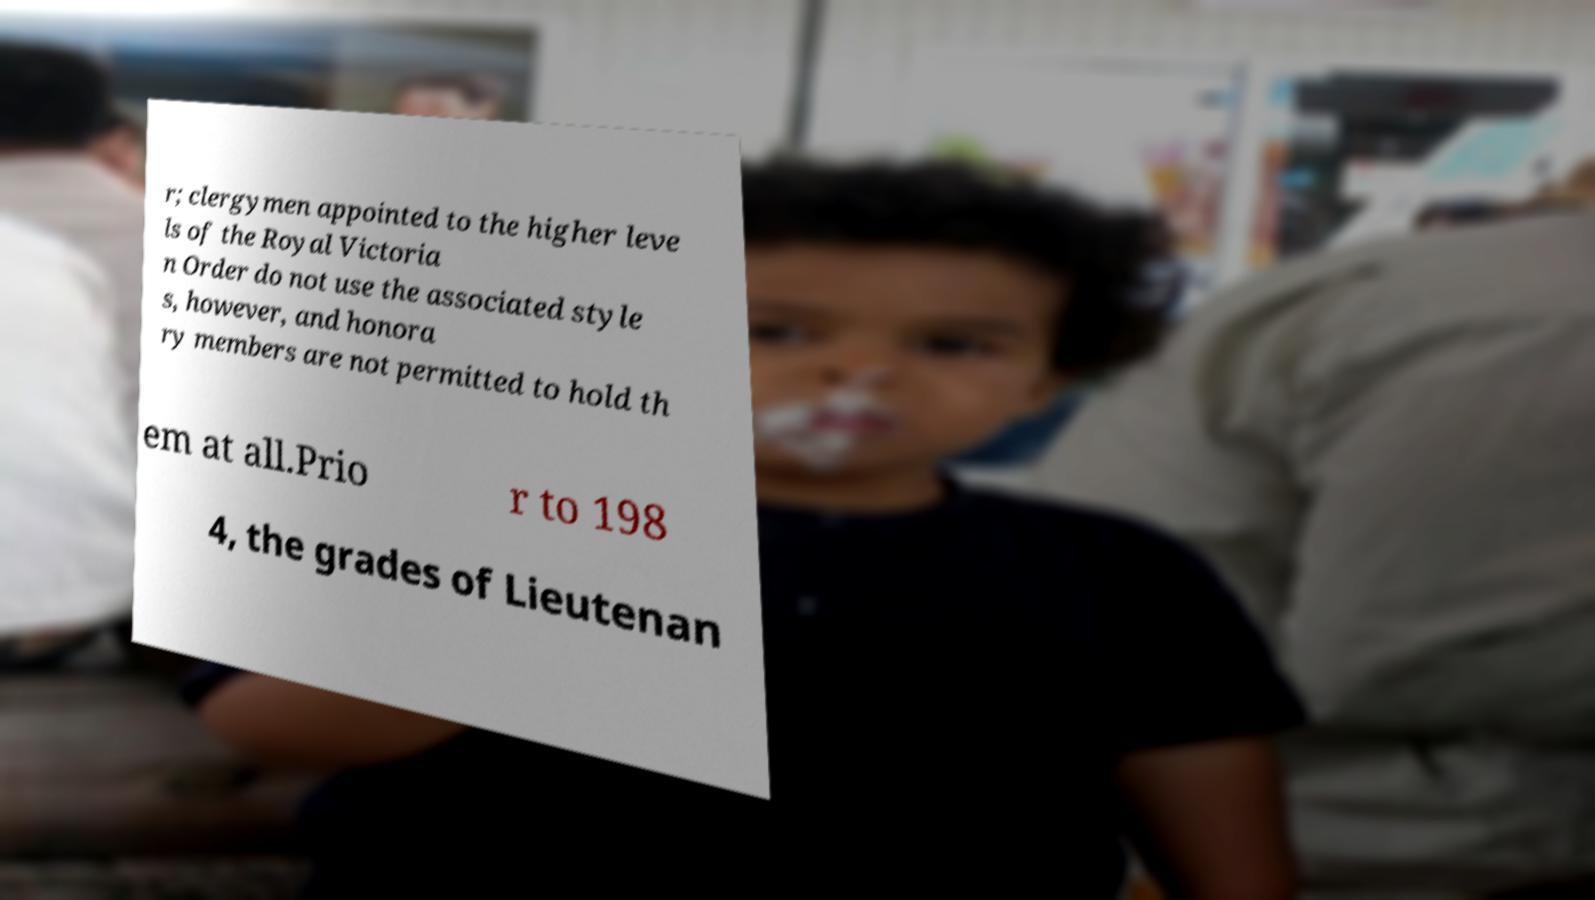I need the written content from this picture converted into text. Can you do that? r; clergymen appointed to the higher leve ls of the Royal Victoria n Order do not use the associated style s, however, and honora ry members are not permitted to hold th em at all.Prio r to 198 4, the grades of Lieutenan 